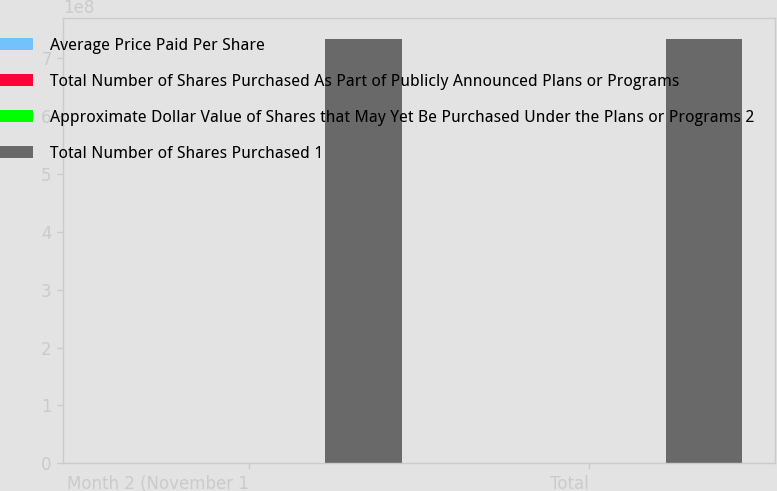Convert chart to OTSL. <chart><loc_0><loc_0><loc_500><loc_500><stacked_bar_chart><ecel><fcel>Month 2 (November 1<fcel>Total<nl><fcel>Average Price Paid Per Share<fcel>400<fcel>894<nl><fcel>Total Number of Shares Purchased As Part of Publicly Announced Plans or Programs<fcel>124<fcel>122.41<nl><fcel>Approximate Dollar Value of Shares that May Yet Be Purchased Under the Plans or Programs 2<fcel>400<fcel>400<nl><fcel>Total Number of Shares Purchased 1<fcel>7.33073e+08<fcel>7.33073e+08<nl></chart> 